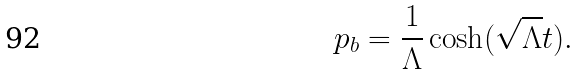<formula> <loc_0><loc_0><loc_500><loc_500>p _ { b } = \frac { 1 } { \Lambda } \cosh ( \sqrt { \Lambda } t ) .</formula> 